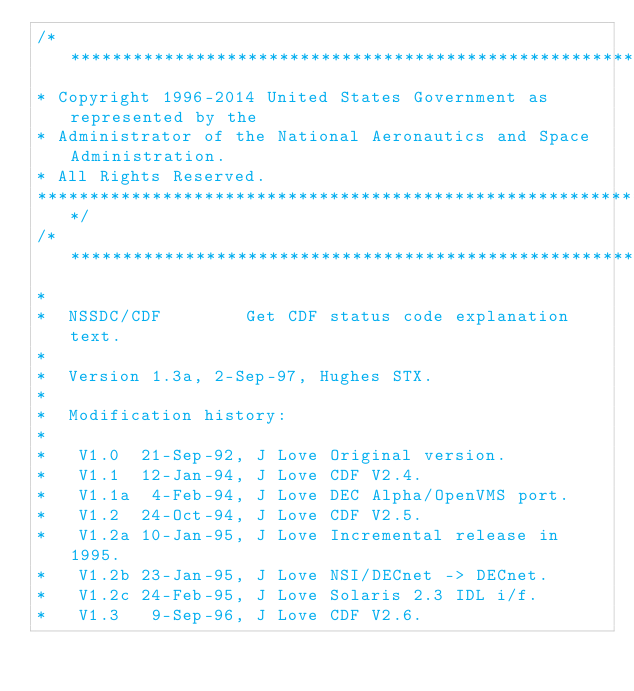Convert code to text. <code><loc_0><loc_0><loc_500><loc_500><_C_>/******************************************************************************
* Copyright 1996-2014 United States Government as represented by the
* Administrator of the National Aeronautics and Space Administration.
* All Rights Reserved.
******************************************************************************/
/******************************************************************************
*
*  NSSDC/CDF				Get CDF status code explanation text.
*
*  Version 1.3a, 2-Sep-97, Hughes STX.
*
*  Modification history:
*
*   V1.0  21-Sep-92, J Love	Original version.
*   V1.1  12-Jan-94, J Love	CDF V2.4.
*   V1.1a  4-Feb-94, J Love	DEC Alpha/OpenVMS port.
*   V1.2  24-Oct-94, J Love	CDF V2.5.
*   V1.2a 10-Jan-95, J Love	Incremental release in 1995.
*   V1.2b 23-Jan-95, J Love	NSI/DECnet -> DECnet.
*   V1.2c 24-Feb-95, J Love	Solaris 2.3 IDL i/f.
*   V1.3   9-Sep-96, J Love	CDF V2.6.</code> 